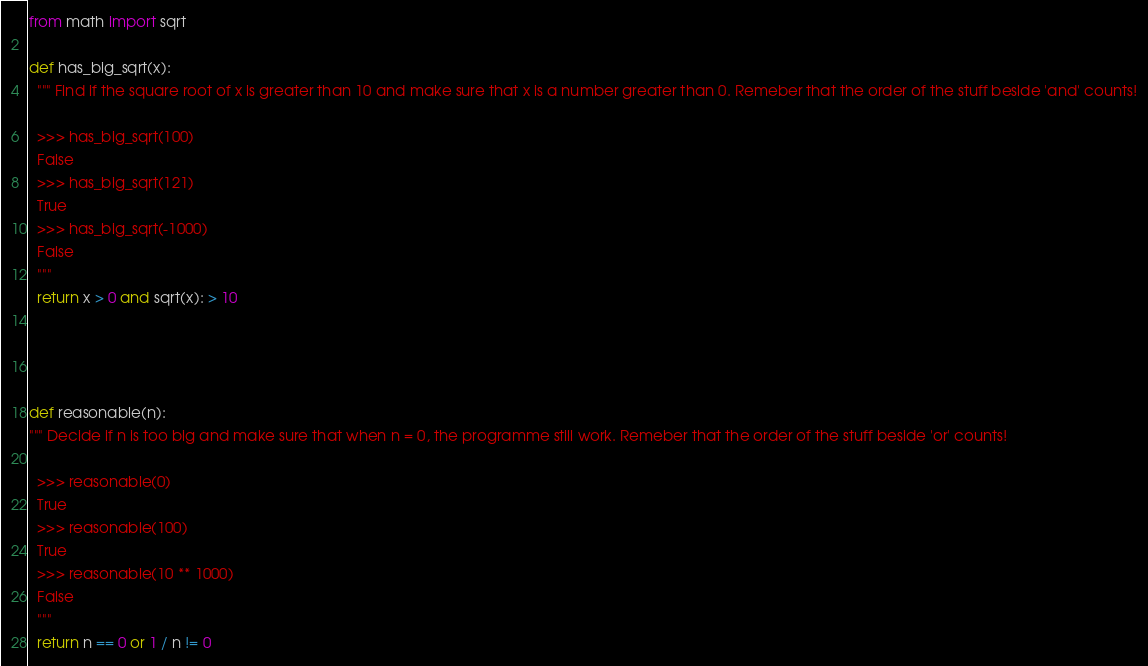<code> <loc_0><loc_0><loc_500><loc_500><_Python_>from math import sqrt

def has_big_sqrt(x):
  """ Find if the square root of x is greater than 10 and make sure that x is a number greater than 0. Remeber that the order of the stuff beside 'and' counts!
  
  >>> has_big_sqrt(100)
  False
  >>> has_big_sqrt(121)
  True
  >>> has_big_sqrt(-1000)
  False
  """
  return x > 0 and sqrt(x): > 10
  
  
  
  
def reasonable(n):
""" Decide if n is too big and make sure that when n = 0, the programme still work. Remeber that the order of the stuff beside 'or' counts!
  
  >>> reasonable(0)
  True
  >>> reasonable(100)
  True
  >>> reasonable(10 ** 1000)
  False
  """
  return n == 0 or 1 / n != 0
</code> 